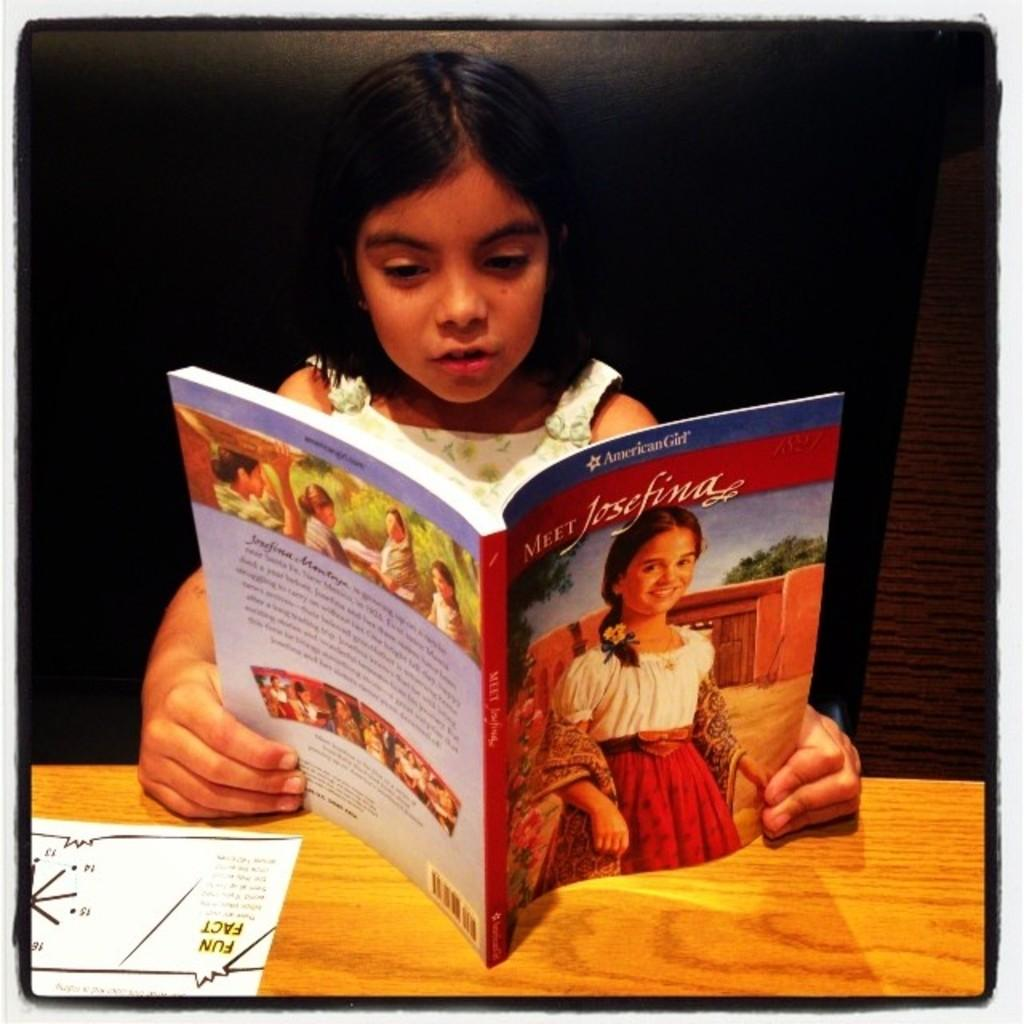<image>
Present a compact description of the photo's key features. Little girl is reading a book about meet Josefina 